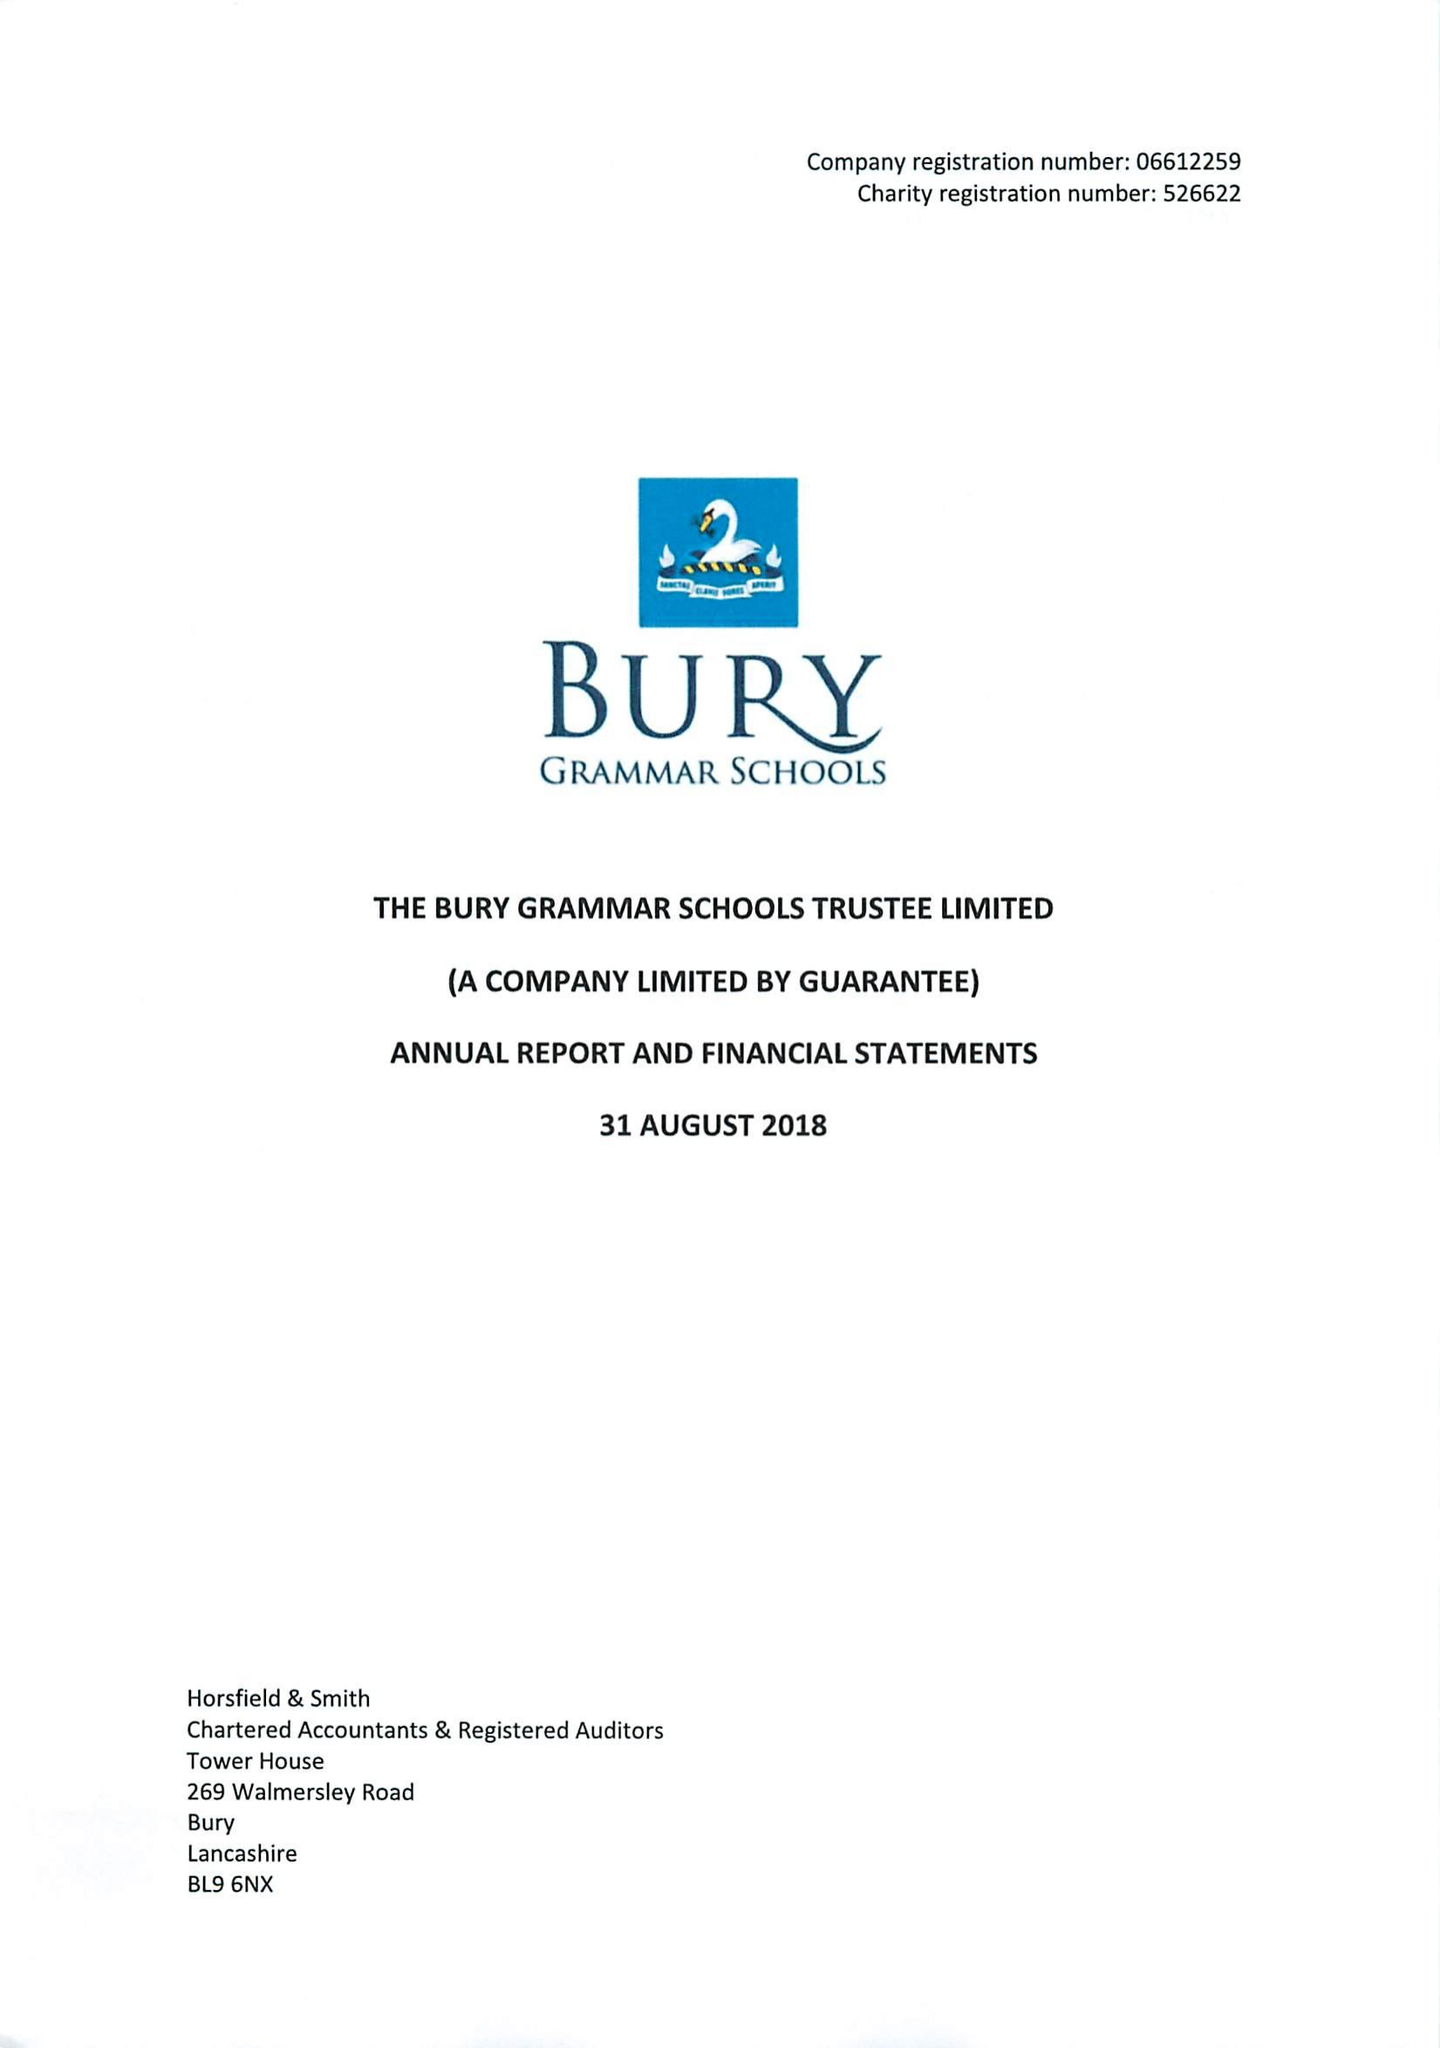What is the value for the charity_number?
Answer the question using a single word or phrase. 526622 